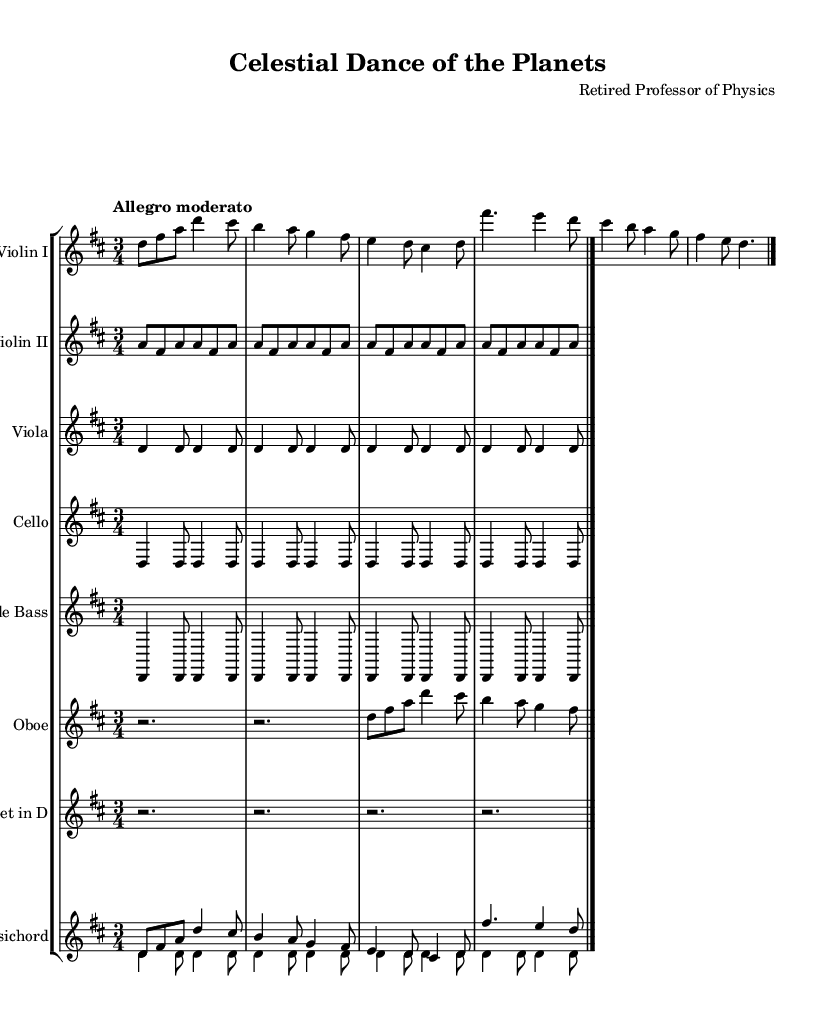What is the key signature of this music? The key signature is indicated at the beginning of the staff. In this case, it shows two sharps, which correspond to D major.
Answer: D major What is the time signature of this music? The time signature is shown at the beginning of the music and indicates how many beats are in a measure. In this case, it is 3/4, meaning there are three beats per measure and the quarter note gets one beat.
Answer: 3/4 What is the tempo marking of this music? The tempo marking is found at the start of the score, specifically the word "Allegro moderato," which indicates a moderately fast tempo.
Answer: Allegro moderato How many instruments are there in this orchestral work? The score lists eight instruments, including two violins, viola, cello, double bass, oboe, trumpet in D, and harpsichord.
Answer: Eight What is the function of the harpsichord in this piece? The harpsichord often plays a continuo role in Baroque music, providing harmonic support. In this score, it plays both a melodic line with the right hand and a bass line with the left hand.
Answer: Continuo What celestial theme is expressed through the title? The title "Celestial Dance of the Planets" suggests a representation of the movements of celestial bodies, indicating an inspiration from astronomy.
Answer: Celestial bodies What is the rhythmic pattern used in the strings throughout the piece? The rhythmic pattern consistently features a combination of quarter and eighth notes, reflecting the typical Baroque style of interweaving melodies and harmonies.
Answer: Quarter and eighth notes 